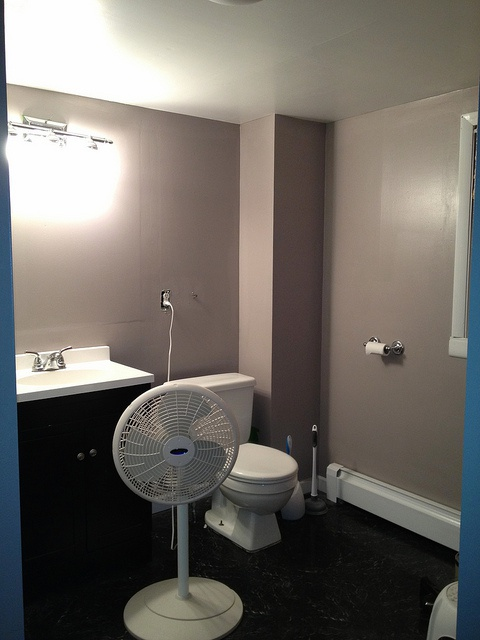Describe the objects in this image and their specific colors. I can see toilet in black, gray, darkgray, and tan tones and sink in black, ivory, and gray tones in this image. 